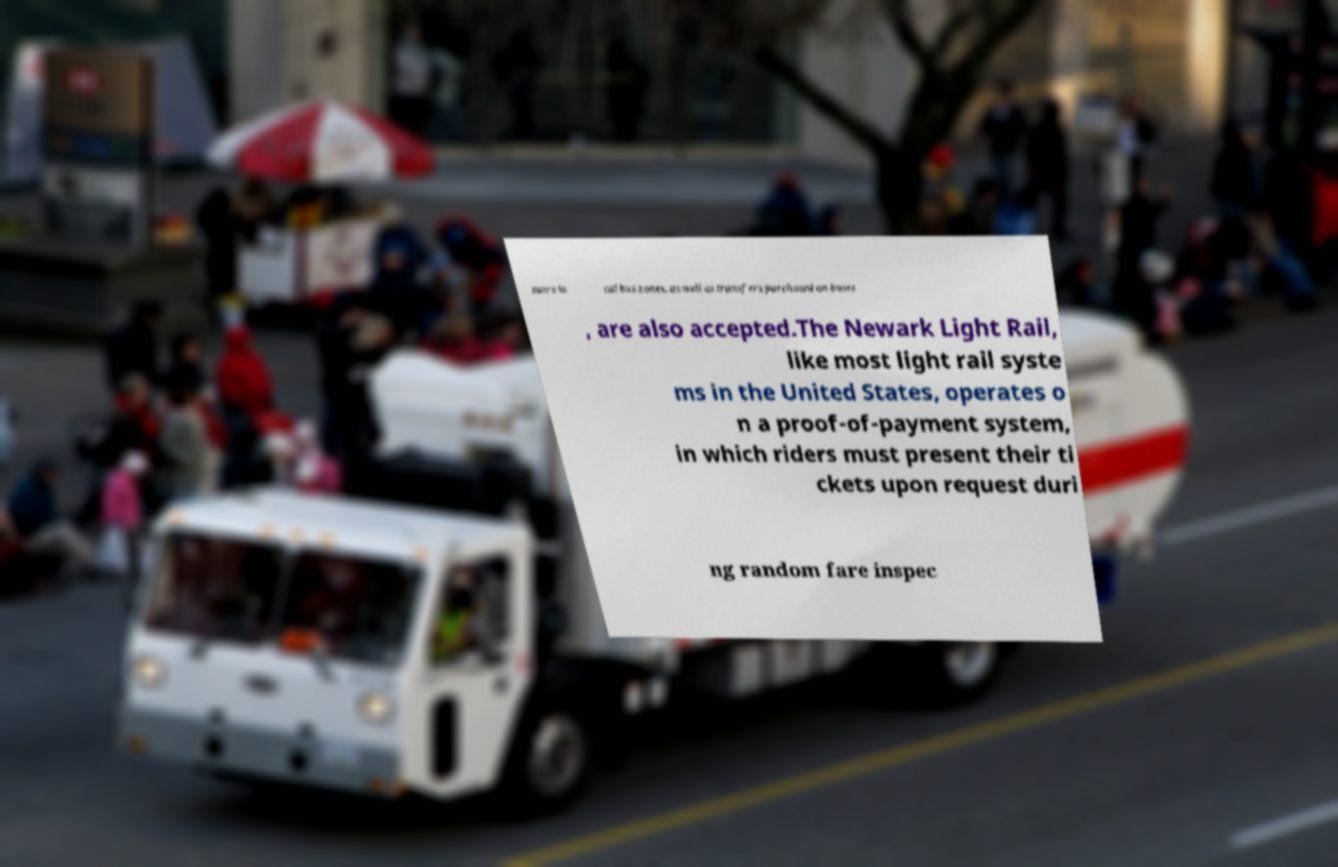Can you accurately transcribe the text from the provided image for me? more lo cal bus zones, as well as transfers purchased on buses , are also accepted.The Newark Light Rail, like most light rail syste ms in the United States, operates o n a proof-of-payment system, in which riders must present their ti ckets upon request duri ng random fare inspec 